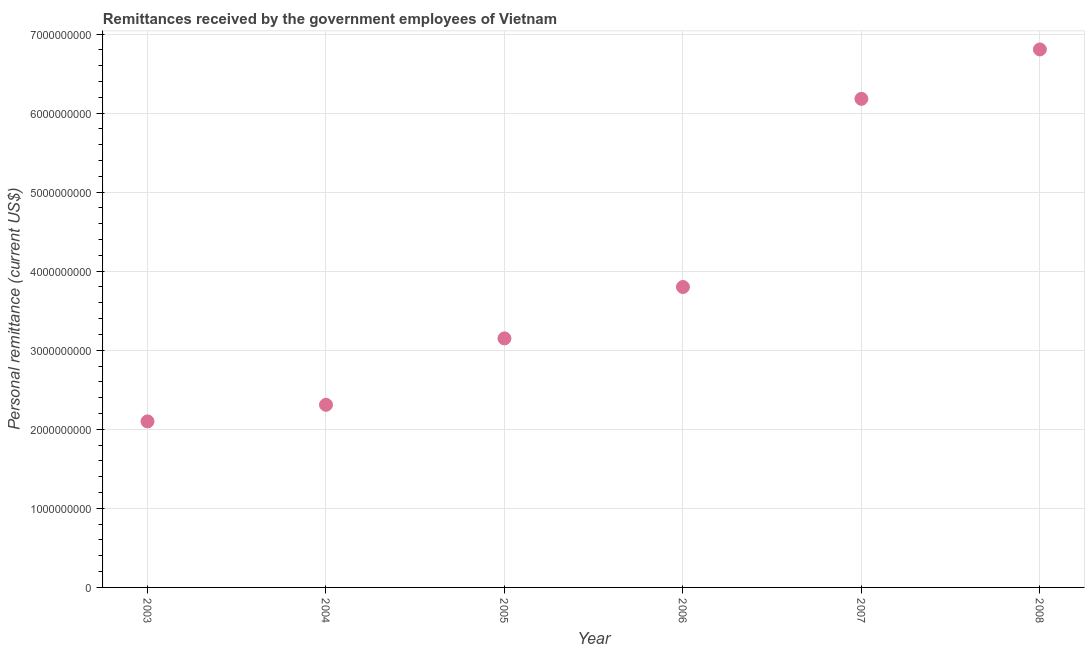What is the personal remittances in 2008?
Keep it short and to the point. 6.80e+09. Across all years, what is the maximum personal remittances?
Your answer should be very brief. 6.80e+09. Across all years, what is the minimum personal remittances?
Provide a succinct answer. 2.10e+09. In which year was the personal remittances maximum?
Your answer should be compact. 2008. In which year was the personal remittances minimum?
Offer a very short reply. 2003. What is the sum of the personal remittances?
Ensure brevity in your answer.  2.43e+1. What is the difference between the personal remittances in 2004 and 2008?
Make the answer very short. -4.50e+09. What is the average personal remittances per year?
Offer a very short reply. 4.06e+09. What is the median personal remittances?
Ensure brevity in your answer.  3.48e+09. In how many years, is the personal remittances greater than 2600000000 US$?
Provide a short and direct response. 4. Do a majority of the years between 2004 and 2008 (inclusive) have personal remittances greater than 1000000000 US$?
Provide a short and direct response. Yes. What is the ratio of the personal remittances in 2004 to that in 2007?
Your answer should be compact. 0.37. Is the personal remittances in 2003 less than that in 2004?
Your answer should be compact. Yes. What is the difference between the highest and the second highest personal remittances?
Offer a terse response. 6.25e+08. Is the sum of the personal remittances in 2005 and 2006 greater than the maximum personal remittances across all years?
Provide a succinct answer. Yes. What is the difference between the highest and the lowest personal remittances?
Your answer should be compact. 4.70e+09. In how many years, is the personal remittances greater than the average personal remittances taken over all years?
Keep it short and to the point. 2. Does the personal remittances monotonically increase over the years?
Keep it short and to the point. Yes. How many dotlines are there?
Ensure brevity in your answer.  1. How many years are there in the graph?
Give a very brief answer. 6. What is the difference between two consecutive major ticks on the Y-axis?
Keep it short and to the point. 1.00e+09. Does the graph contain grids?
Provide a short and direct response. Yes. What is the title of the graph?
Provide a short and direct response. Remittances received by the government employees of Vietnam. What is the label or title of the Y-axis?
Keep it short and to the point. Personal remittance (current US$). What is the Personal remittance (current US$) in 2003?
Ensure brevity in your answer.  2.10e+09. What is the Personal remittance (current US$) in 2004?
Provide a succinct answer. 2.31e+09. What is the Personal remittance (current US$) in 2005?
Give a very brief answer. 3.15e+09. What is the Personal remittance (current US$) in 2006?
Ensure brevity in your answer.  3.80e+09. What is the Personal remittance (current US$) in 2007?
Give a very brief answer. 6.18e+09. What is the Personal remittance (current US$) in 2008?
Offer a very short reply. 6.80e+09. What is the difference between the Personal remittance (current US$) in 2003 and 2004?
Ensure brevity in your answer.  -2.10e+08. What is the difference between the Personal remittance (current US$) in 2003 and 2005?
Your answer should be very brief. -1.05e+09. What is the difference between the Personal remittance (current US$) in 2003 and 2006?
Offer a terse response. -1.70e+09. What is the difference between the Personal remittance (current US$) in 2003 and 2007?
Ensure brevity in your answer.  -4.08e+09. What is the difference between the Personal remittance (current US$) in 2003 and 2008?
Offer a terse response. -4.70e+09. What is the difference between the Personal remittance (current US$) in 2004 and 2005?
Offer a terse response. -8.40e+08. What is the difference between the Personal remittance (current US$) in 2004 and 2006?
Ensure brevity in your answer.  -1.49e+09. What is the difference between the Personal remittance (current US$) in 2004 and 2007?
Make the answer very short. -3.87e+09. What is the difference between the Personal remittance (current US$) in 2004 and 2008?
Ensure brevity in your answer.  -4.50e+09. What is the difference between the Personal remittance (current US$) in 2005 and 2006?
Your response must be concise. -6.50e+08. What is the difference between the Personal remittance (current US$) in 2005 and 2007?
Provide a succinct answer. -3.03e+09. What is the difference between the Personal remittance (current US$) in 2005 and 2008?
Offer a terse response. -3.66e+09. What is the difference between the Personal remittance (current US$) in 2006 and 2007?
Give a very brief answer. -2.38e+09. What is the difference between the Personal remittance (current US$) in 2006 and 2008?
Offer a very short reply. -3.00e+09. What is the difference between the Personal remittance (current US$) in 2007 and 2008?
Keep it short and to the point. -6.25e+08. What is the ratio of the Personal remittance (current US$) in 2003 to that in 2004?
Your response must be concise. 0.91. What is the ratio of the Personal remittance (current US$) in 2003 to that in 2005?
Offer a very short reply. 0.67. What is the ratio of the Personal remittance (current US$) in 2003 to that in 2006?
Provide a short and direct response. 0.55. What is the ratio of the Personal remittance (current US$) in 2003 to that in 2007?
Provide a short and direct response. 0.34. What is the ratio of the Personal remittance (current US$) in 2003 to that in 2008?
Offer a terse response. 0.31. What is the ratio of the Personal remittance (current US$) in 2004 to that in 2005?
Make the answer very short. 0.73. What is the ratio of the Personal remittance (current US$) in 2004 to that in 2006?
Your answer should be compact. 0.61. What is the ratio of the Personal remittance (current US$) in 2004 to that in 2007?
Give a very brief answer. 0.37. What is the ratio of the Personal remittance (current US$) in 2004 to that in 2008?
Offer a terse response. 0.34. What is the ratio of the Personal remittance (current US$) in 2005 to that in 2006?
Ensure brevity in your answer.  0.83. What is the ratio of the Personal remittance (current US$) in 2005 to that in 2007?
Provide a succinct answer. 0.51. What is the ratio of the Personal remittance (current US$) in 2005 to that in 2008?
Make the answer very short. 0.46. What is the ratio of the Personal remittance (current US$) in 2006 to that in 2007?
Your answer should be compact. 0.61. What is the ratio of the Personal remittance (current US$) in 2006 to that in 2008?
Make the answer very short. 0.56. What is the ratio of the Personal remittance (current US$) in 2007 to that in 2008?
Offer a very short reply. 0.91. 